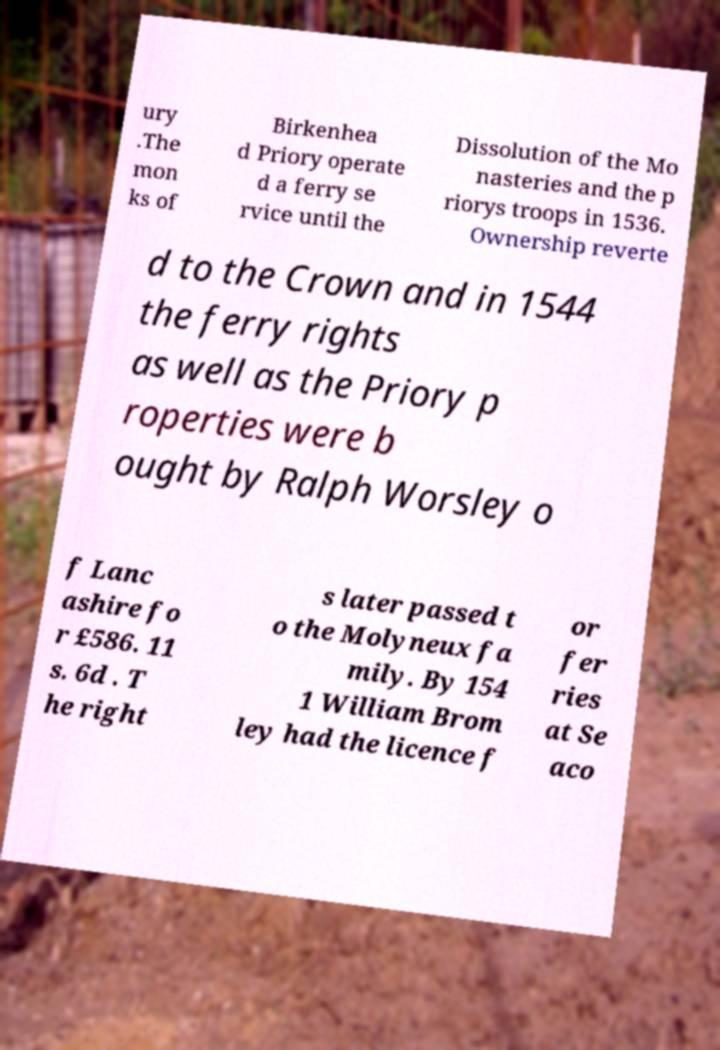Could you extract and type out the text from this image? ury .The mon ks of Birkenhea d Priory operate d a ferry se rvice until the Dissolution of the Mo nasteries and the p riorys troops in 1536. Ownership reverte d to the Crown and in 1544 the ferry rights as well as the Priory p roperties were b ought by Ralph Worsley o f Lanc ashire fo r £586. 11 s. 6d . T he right s later passed t o the Molyneux fa mily. By 154 1 William Brom ley had the licence f or fer ries at Se aco 